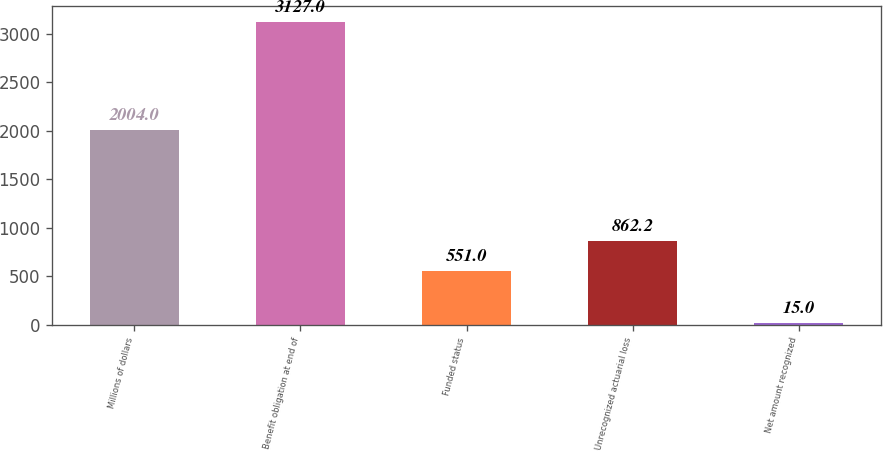Convert chart. <chart><loc_0><loc_0><loc_500><loc_500><bar_chart><fcel>Millions of dollars<fcel>Benefit obligation at end of<fcel>Funded status<fcel>Unrecognized actuarial loss<fcel>Net amount recognized<nl><fcel>2004<fcel>3127<fcel>551<fcel>862.2<fcel>15<nl></chart> 